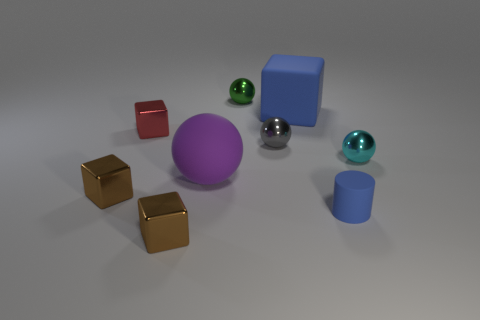What number of spheres are either big things or tiny cyan metallic things?
Make the answer very short. 2. Is the number of green balls on the left side of the green ball the same as the number of large cyan blocks?
Offer a terse response. Yes. There is a cube in front of the blue thing that is in front of the tiny object to the right of the tiny blue rubber cylinder; what is it made of?
Offer a very short reply. Metal. How many things are either metal objects right of the purple sphere or yellow objects?
Keep it short and to the point. 3. What number of things are either matte things or small metal objects that are to the right of the big blue block?
Keep it short and to the point. 4. There is a brown shiny block to the right of the small brown cube that is left of the red metal cube; what number of blue matte objects are behind it?
Ensure brevity in your answer.  2. What material is the green ball that is the same size as the cyan shiny sphere?
Offer a terse response. Metal. Are there any blue things that have the same size as the red metal thing?
Make the answer very short. Yes. The rubber cylinder has what color?
Your answer should be compact. Blue. There is a block that is to the right of the small thing that is behind the big blue thing; what is its color?
Offer a very short reply. Blue. 